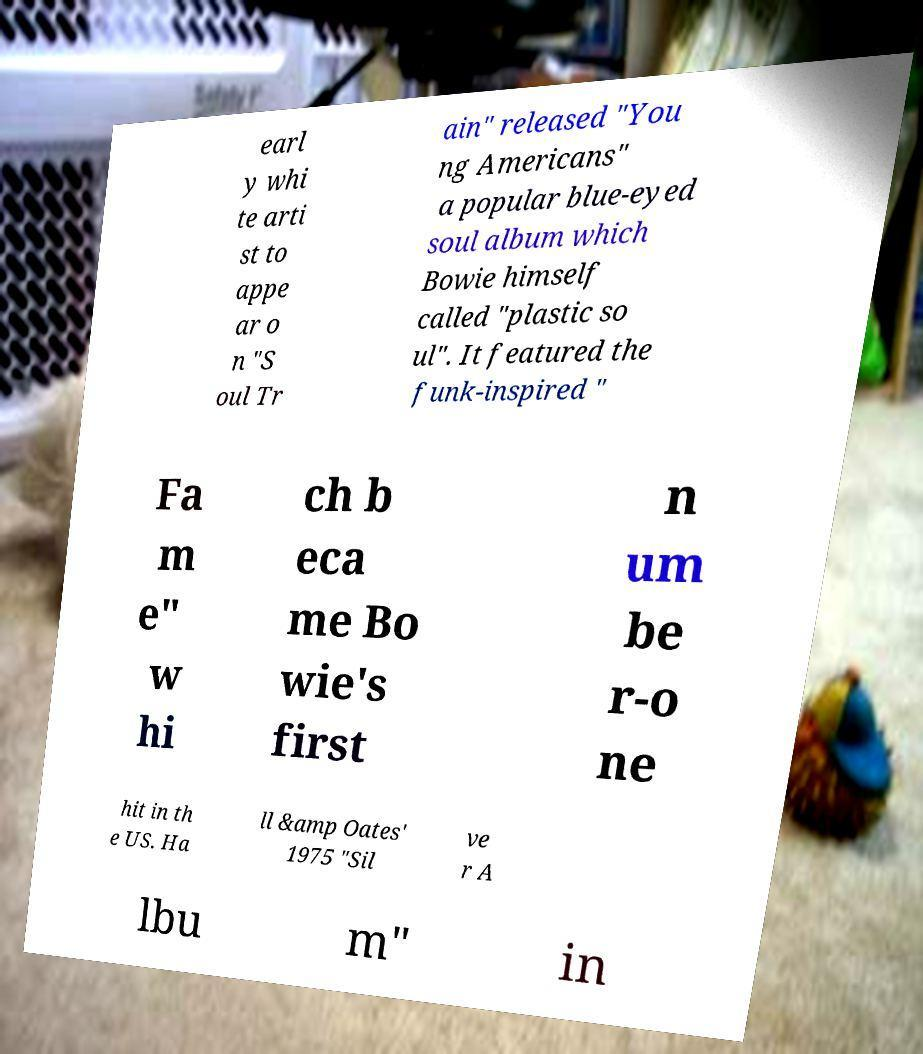Could you extract and type out the text from this image? earl y whi te arti st to appe ar o n "S oul Tr ain" released "You ng Americans" a popular blue-eyed soul album which Bowie himself called "plastic so ul". It featured the funk-inspired " Fa m e" w hi ch b eca me Bo wie's first n um be r-o ne hit in th e US. Ha ll &amp Oates' 1975 "Sil ve r A lbu m" in 